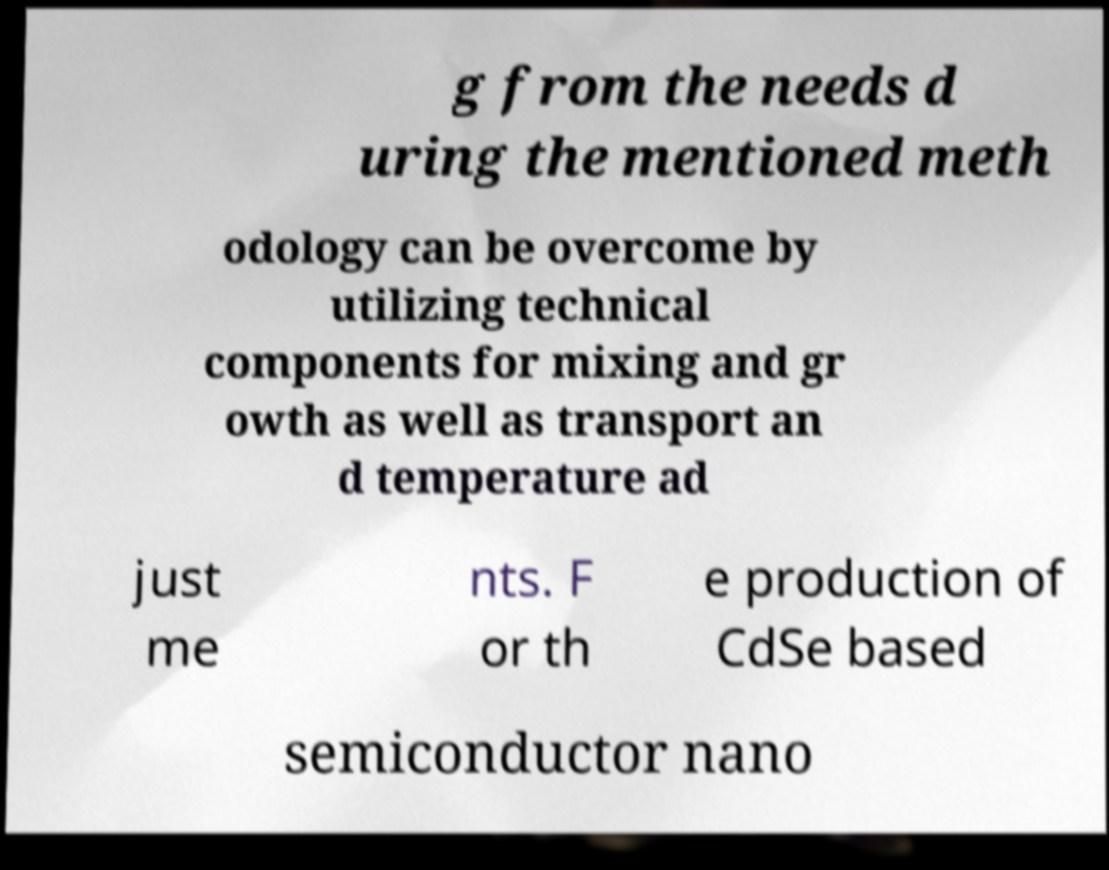I need the written content from this picture converted into text. Can you do that? g from the needs d uring the mentioned meth odology can be overcome by utilizing technical components for mixing and gr owth as well as transport an d temperature ad just me nts. F or th e production of CdSe based semiconductor nano 